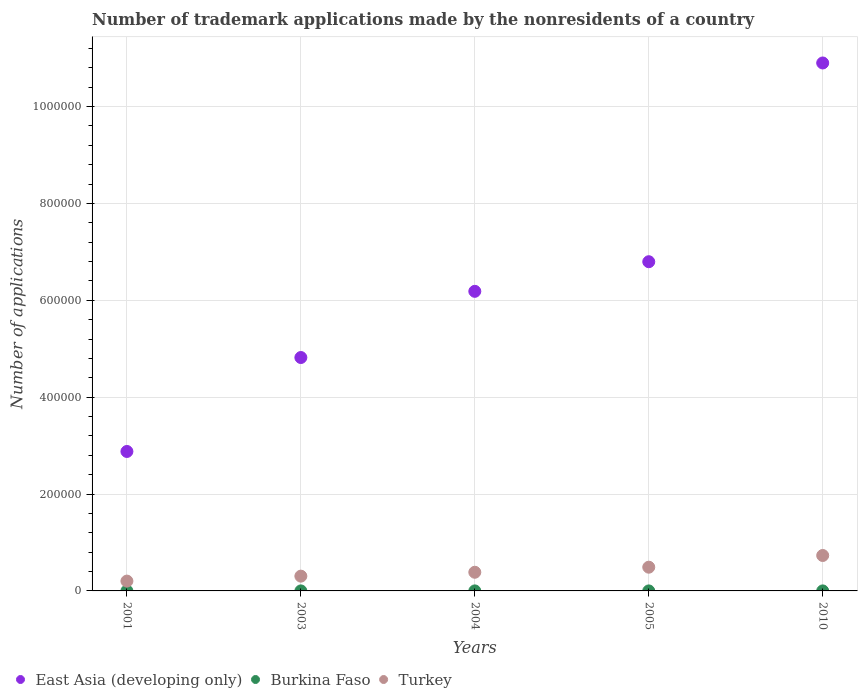Is the number of dotlines equal to the number of legend labels?
Keep it short and to the point. Yes. What is the number of trademark applications made by the nonresidents in East Asia (developing only) in 2010?
Provide a short and direct response. 1.09e+06. Across all years, what is the maximum number of trademark applications made by the nonresidents in East Asia (developing only)?
Give a very brief answer. 1.09e+06. Across all years, what is the minimum number of trademark applications made by the nonresidents in Turkey?
Offer a very short reply. 2.03e+04. In which year was the number of trademark applications made by the nonresidents in Burkina Faso minimum?
Offer a very short reply. 2001. What is the total number of trademark applications made by the nonresidents in Turkey in the graph?
Your answer should be compact. 2.11e+05. What is the difference between the number of trademark applications made by the nonresidents in East Asia (developing only) in 2001 and that in 2003?
Keep it short and to the point. -1.94e+05. What is the difference between the number of trademark applications made by the nonresidents in Turkey in 2004 and the number of trademark applications made by the nonresidents in Burkina Faso in 2001?
Give a very brief answer. 3.85e+04. What is the average number of trademark applications made by the nonresidents in Turkey per year?
Offer a terse response. 4.23e+04. In the year 2001, what is the difference between the number of trademark applications made by the nonresidents in Turkey and number of trademark applications made by the nonresidents in East Asia (developing only)?
Keep it short and to the point. -2.68e+05. In how many years, is the number of trademark applications made by the nonresidents in East Asia (developing only) greater than 560000?
Your response must be concise. 3. What is the ratio of the number of trademark applications made by the nonresidents in Burkina Faso in 2003 to that in 2010?
Provide a short and direct response. 1.03. Is the number of trademark applications made by the nonresidents in Burkina Faso in 2001 less than that in 2004?
Ensure brevity in your answer.  Yes. Is the difference between the number of trademark applications made by the nonresidents in Turkey in 2001 and 2005 greater than the difference between the number of trademark applications made by the nonresidents in East Asia (developing only) in 2001 and 2005?
Provide a succinct answer. Yes. What is the difference between the highest and the second highest number of trademark applications made by the nonresidents in Turkey?
Make the answer very short. 2.42e+04. Is the sum of the number of trademark applications made by the nonresidents in Turkey in 2003 and 2004 greater than the maximum number of trademark applications made by the nonresidents in Burkina Faso across all years?
Provide a short and direct response. Yes. Is it the case that in every year, the sum of the number of trademark applications made by the nonresidents in East Asia (developing only) and number of trademark applications made by the nonresidents in Burkina Faso  is greater than the number of trademark applications made by the nonresidents in Turkey?
Your answer should be very brief. Yes. How many dotlines are there?
Ensure brevity in your answer.  3. How many years are there in the graph?
Your response must be concise. 5. Are the values on the major ticks of Y-axis written in scientific E-notation?
Provide a short and direct response. No. How many legend labels are there?
Provide a short and direct response. 3. What is the title of the graph?
Your answer should be compact. Number of trademark applications made by the nonresidents of a country. What is the label or title of the Y-axis?
Ensure brevity in your answer.  Number of applications. What is the Number of applications in East Asia (developing only) in 2001?
Ensure brevity in your answer.  2.88e+05. What is the Number of applications of Burkina Faso in 2001?
Make the answer very short. 15. What is the Number of applications of Turkey in 2001?
Offer a very short reply. 2.03e+04. What is the Number of applications in East Asia (developing only) in 2003?
Ensure brevity in your answer.  4.82e+05. What is the Number of applications in Burkina Faso in 2003?
Ensure brevity in your answer.  35. What is the Number of applications of Turkey in 2003?
Provide a succinct answer. 3.05e+04. What is the Number of applications in East Asia (developing only) in 2004?
Offer a terse response. 6.18e+05. What is the Number of applications in Burkina Faso in 2004?
Your answer should be compact. 42. What is the Number of applications of Turkey in 2004?
Keep it short and to the point. 3.85e+04. What is the Number of applications of East Asia (developing only) in 2005?
Provide a short and direct response. 6.80e+05. What is the Number of applications of Turkey in 2005?
Your answer should be compact. 4.90e+04. What is the Number of applications of East Asia (developing only) in 2010?
Your answer should be very brief. 1.09e+06. What is the Number of applications in Burkina Faso in 2010?
Offer a terse response. 34. What is the Number of applications in Turkey in 2010?
Ensure brevity in your answer.  7.31e+04. Across all years, what is the maximum Number of applications in East Asia (developing only)?
Ensure brevity in your answer.  1.09e+06. Across all years, what is the maximum Number of applications of Burkina Faso?
Ensure brevity in your answer.  42. Across all years, what is the maximum Number of applications of Turkey?
Provide a succinct answer. 7.31e+04. Across all years, what is the minimum Number of applications of East Asia (developing only)?
Give a very brief answer. 2.88e+05. Across all years, what is the minimum Number of applications of Burkina Faso?
Provide a short and direct response. 15. Across all years, what is the minimum Number of applications of Turkey?
Offer a very short reply. 2.03e+04. What is the total Number of applications in East Asia (developing only) in the graph?
Offer a terse response. 3.16e+06. What is the total Number of applications in Burkina Faso in the graph?
Keep it short and to the point. 156. What is the total Number of applications in Turkey in the graph?
Your response must be concise. 2.11e+05. What is the difference between the Number of applications in East Asia (developing only) in 2001 and that in 2003?
Keep it short and to the point. -1.94e+05. What is the difference between the Number of applications in Burkina Faso in 2001 and that in 2003?
Give a very brief answer. -20. What is the difference between the Number of applications of Turkey in 2001 and that in 2003?
Offer a terse response. -1.02e+04. What is the difference between the Number of applications of East Asia (developing only) in 2001 and that in 2004?
Keep it short and to the point. -3.31e+05. What is the difference between the Number of applications in Burkina Faso in 2001 and that in 2004?
Your answer should be compact. -27. What is the difference between the Number of applications of Turkey in 2001 and that in 2004?
Your answer should be very brief. -1.82e+04. What is the difference between the Number of applications of East Asia (developing only) in 2001 and that in 2005?
Your response must be concise. -3.92e+05. What is the difference between the Number of applications in Turkey in 2001 and that in 2005?
Your response must be concise. -2.87e+04. What is the difference between the Number of applications of East Asia (developing only) in 2001 and that in 2010?
Your answer should be compact. -8.02e+05. What is the difference between the Number of applications in Burkina Faso in 2001 and that in 2010?
Make the answer very short. -19. What is the difference between the Number of applications in Turkey in 2001 and that in 2010?
Provide a short and direct response. -5.29e+04. What is the difference between the Number of applications in East Asia (developing only) in 2003 and that in 2004?
Your answer should be compact. -1.37e+05. What is the difference between the Number of applications of Turkey in 2003 and that in 2004?
Keep it short and to the point. -8017. What is the difference between the Number of applications of East Asia (developing only) in 2003 and that in 2005?
Keep it short and to the point. -1.98e+05. What is the difference between the Number of applications of Turkey in 2003 and that in 2005?
Your answer should be compact. -1.85e+04. What is the difference between the Number of applications in East Asia (developing only) in 2003 and that in 2010?
Offer a very short reply. -6.08e+05. What is the difference between the Number of applications of Turkey in 2003 and that in 2010?
Provide a short and direct response. -4.26e+04. What is the difference between the Number of applications in East Asia (developing only) in 2004 and that in 2005?
Provide a succinct answer. -6.11e+04. What is the difference between the Number of applications of Burkina Faso in 2004 and that in 2005?
Offer a very short reply. 12. What is the difference between the Number of applications of Turkey in 2004 and that in 2005?
Provide a succinct answer. -1.05e+04. What is the difference between the Number of applications of East Asia (developing only) in 2004 and that in 2010?
Ensure brevity in your answer.  -4.71e+05. What is the difference between the Number of applications of Burkina Faso in 2004 and that in 2010?
Provide a succinct answer. 8. What is the difference between the Number of applications of Turkey in 2004 and that in 2010?
Ensure brevity in your answer.  -3.46e+04. What is the difference between the Number of applications of East Asia (developing only) in 2005 and that in 2010?
Provide a succinct answer. -4.10e+05. What is the difference between the Number of applications of Turkey in 2005 and that in 2010?
Make the answer very short. -2.42e+04. What is the difference between the Number of applications in East Asia (developing only) in 2001 and the Number of applications in Burkina Faso in 2003?
Give a very brief answer. 2.88e+05. What is the difference between the Number of applications in East Asia (developing only) in 2001 and the Number of applications in Turkey in 2003?
Ensure brevity in your answer.  2.57e+05. What is the difference between the Number of applications in Burkina Faso in 2001 and the Number of applications in Turkey in 2003?
Provide a succinct answer. -3.05e+04. What is the difference between the Number of applications of East Asia (developing only) in 2001 and the Number of applications of Burkina Faso in 2004?
Give a very brief answer. 2.88e+05. What is the difference between the Number of applications in East Asia (developing only) in 2001 and the Number of applications in Turkey in 2004?
Keep it short and to the point. 2.49e+05. What is the difference between the Number of applications of Burkina Faso in 2001 and the Number of applications of Turkey in 2004?
Offer a terse response. -3.85e+04. What is the difference between the Number of applications of East Asia (developing only) in 2001 and the Number of applications of Burkina Faso in 2005?
Make the answer very short. 2.88e+05. What is the difference between the Number of applications in East Asia (developing only) in 2001 and the Number of applications in Turkey in 2005?
Ensure brevity in your answer.  2.39e+05. What is the difference between the Number of applications in Burkina Faso in 2001 and the Number of applications in Turkey in 2005?
Make the answer very short. -4.90e+04. What is the difference between the Number of applications in East Asia (developing only) in 2001 and the Number of applications in Burkina Faso in 2010?
Provide a short and direct response. 2.88e+05. What is the difference between the Number of applications in East Asia (developing only) in 2001 and the Number of applications in Turkey in 2010?
Your answer should be very brief. 2.15e+05. What is the difference between the Number of applications of Burkina Faso in 2001 and the Number of applications of Turkey in 2010?
Your answer should be very brief. -7.31e+04. What is the difference between the Number of applications of East Asia (developing only) in 2003 and the Number of applications of Burkina Faso in 2004?
Your answer should be compact. 4.82e+05. What is the difference between the Number of applications of East Asia (developing only) in 2003 and the Number of applications of Turkey in 2004?
Offer a terse response. 4.43e+05. What is the difference between the Number of applications of Burkina Faso in 2003 and the Number of applications of Turkey in 2004?
Provide a succinct answer. -3.85e+04. What is the difference between the Number of applications in East Asia (developing only) in 2003 and the Number of applications in Burkina Faso in 2005?
Provide a short and direct response. 4.82e+05. What is the difference between the Number of applications of East Asia (developing only) in 2003 and the Number of applications of Turkey in 2005?
Offer a very short reply. 4.33e+05. What is the difference between the Number of applications of Burkina Faso in 2003 and the Number of applications of Turkey in 2005?
Your answer should be very brief. -4.89e+04. What is the difference between the Number of applications in East Asia (developing only) in 2003 and the Number of applications in Burkina Faso in 2010?
Keep it short and to the point. 4.82e+05. What is the difference between the Number of applications in East Asia (developing only) in 2003 and the Number of applications in Turkey in 2010?
Ensure brevity in your answer.  4.09e+05. What is the difference between the Number of applications in Burkina Faso in 2003 and the Number of applications in Turkey in 2010?
Make the answer very short. -7.31e+04. What is the difference between the Number of applications in East Asia (developing only) in 2004 and the Number of applications in Burkina Faso in 2005?
Offer a very short reply. 6.18e+05. What is the difference between the Number of applications in East Asia (developing only) in 2004 and the Number of applications in Turkey in 2005?
Your answer should be very brief. 5.69e+05. What is the difference between the Number of applications of Burkina Faso in 2004 and the Number of applications of Turkey in 2005?
Your answer should be compact. -4.89e+04. What is the difference between the Number of applications of East Asia (developing only) in 2004 and the Number of applications of Burkina Faso in 2010?
Provide a succinct answer. 6.18e+05. What is the difference between the Number of applications in East Asia (developing only) in 2004 and the Number of applications in Turkey in 2010?
Give a very brief answer. 5.45e+05. What is the difference between the Number of applications of Burkina Faso in 2004 and the Number of applications of Turkey in 2010?
Provide a short and direct response. -7.31e+04. What is the difference between the Number of applications in East Asia (developing only) in 2005 and the Number of applications in Burkina Faso in 2010?
Offer a terse response. 6.80e+05. What is the difference between the Number of applications in East Asia (developing only) in 2005 and the Number of applications in Turkey in 2010?
Offer a terse response. 6.06e+05. What is the difference between the Number of applications of Burkina Faso in 2005 and the Number of applications of Turkey in 2010?
Make the answer very short. -7.31e+04. What is the average Number of applications in East Asia (developing only) per year?
Your answer should be compact. 6.32e+05. What is the average Number of applications of Burkina Faso per year?
Ensure brevity in your answer.  31.2. What is the average Number of applications of Turkey per year?
Give a very brief answer. 4.23e+04. In the year 2001, what is the difference between the Number of applications in East Asia (developing only) and Number of applications in Burkina Faso?
Keep it short and to the point. 2.88e+05. In the year 2001, what is the difference between the Number of applications in East Asia (developing only) and Number of applications in Turkey?
Offer a terse response. 2.68e+05. In the year 2001, what is the difference between the Number of applications in Burkina Faso and Number of applications in Turkey?
Your answer should be compact. -2.03e+04. In the year 2003, what is the difference between the Number of applications in East Asia (developing only) and Number of applications in Burkina Faso?
Make the answer very short. 4.82e+05. In the year 2003, what is the difference between the Number of applications of East Asia (developing only) and Number of applications of Turkey?
Your response must be concise. 4.51e+05. In the year 2003, what is the difference between the Number of applications of Burkina Faso and Number of applications of Turkey?
Keep it short and to the point. -3.05e+04. In the year 2004, what is the difference between the Number of applications in East Asia (developing only) and Number of applications in Burkina Faso?
Make the answer very short. 6.18e+05. In the year 2004, what is the difference between the Number of applications of East Asia (developing only) and Number of applications of Turkey?
Offer a terse response. 5.80e+05. In the year 2004, what is the difference between the Number of applications of Burkina Faso and Number of applications of Turkey?
Ensure brevity in your answer.  -3.85e+04. In the year 2005, what is the difference between the Number of applications of East Asia (developing only) and Number of applications of Burkina Faso?
Give a very brief answer. 6.80e+05. In the year 2005, what is the difference between the Number of applications of East Asia (developing only) and Number of applications of Turkey?
Keep it short and to the point. 6.31e+05. In the year 2005, what is the difference between the Number of applications in Burkina Faso and Number of applications in Turkey?
Ensure brevity in your answer.  -4.90e+04. In the year 2010, what is the difference between the Number of applications of East Asia (developing only) and Number of applications of Burkina Faso?
Offer a very short reply. 1.09e+06. In the year 2010, what is the difference between the Number of applications in East Asia (developing only) and Number of applications in Turkey?
Provide a succinct answer. 1.02e+06. In the year 2010, what is the difference between the Number of applications in Burkina Faso and Number of applications in Turkey?
Ensure brevity in your answer.  -7.31e+04. What is the ratio of the Number of applications in East Asia (developing only) in 2001 to that in 2003?
Provide a succinct answer. 0.6. What is the ratio of the Number of applications of Burkina Faso in 2001 to that in 2003?
Ensure brevity in your answer.  0.43. What is the ratio of the Number of applications of Turkey in 2001 to that in 2003?
Provide a short and direct response. 0.67. What is the ratio of the Number of applications of East Asia (developing only) in 2001 to that in 2004?
Provide a short and direct response. 0.47. What is the ratio of the Number of applications in Burkina Faso in 2001 to that in 2004?
Give a very brief answer. 0.36. What is the ratio of the Number of applications of Turkey in 2001 to that in 2004?
Provide a short and direct response. 0.53. What is the ratio of the Number of applications in East Asia (developing only) in 2001 to that in 2005?
Give a very brief answer. 0.42. What is the ratio of the Number of applications of Burkina Faso in 2001 to that in 2005?
Your answer should be very brief. 0.5. What is the ratio of the Number of applications in Turkey in 2001 to that in 2005?
Provide a succinct answer. 0.41. What is the ratio of the Number of applications of East Asia (developing only) in 2001 to that in 2010?
Offer a very short reply. 0.26. What is the ratio of the Number of applications of Burkina Faso in 2001 to that in 2010?
Your answer should be very brief. 0.44. What is the ratio of the Number of applications of Turkey in 2001 to that in 2010?
Make the answer very short. 0.28. What is the ratio of the Number of applications of East Asia (developing only) in 2003 to that in 2004?
Your response must be concise. 0.78. What is the ratio of the Number of applications of Turkey in 2003 to that in 2004?
Make the answer very short. 0.79. What is the ratio of the Number of applications of East Asia (developing only) in 2003 to that in 2005?
Provide a succinct answer. 0.71. What is the ratio of the Number of applications in Turkey in 2003 to that in 2005?
Give a very brief answer. 0.62. What is the ratio of the Number of applications of East Asia (developing only) in 2003 to that in 2010?
Offer a terse response. 0.44. What is the ratio of the Number of applications in Burkina Faso in 2003 to that in 2010?
Provide a short and direct response. 1.03. What is the ratio of the Number of applications of Turkey in 2003 to that in 2010?
Provide a succinct answer. 0.42. What is the ratio of the Number of applications in East Asia (developing only) in 2004 to that in 2005?
Make the answer very short. 0.91. What is the ratio of the Number of applications in Burkina Faso in 2004 to that in 2005?
Offer a terse response. 1.4. What is the ratio of the Number of applications in Turkey in 2004 to that in 2005?
Your response must be concise. 0.79. What is the ratio of the Number of applications in East Asia (developing only) in 2004 to that in 2010?
Give a very brief answer. 0.57. What is the ratio of the Number of applications of Burkina Faso in 2004 to that in 2010?
Provide a succinct answer. 1.24. What is the ratio of the Number of applications of Turkey in 2004 to that in 2010?
Offer a terse response. 0.53. What is the ratio of the Number of applications in East Asia (developing only) in 2005 to that in 2010?
Ensure brevity in your answer.  0.62. What is the ratio of the Number of applications of Burkina Faso in 2005 to that in 2010?
Your answer should be very brief. 0.88. What is the ratio of the Number of applications of Turkey in 2005 to that in 2010?
Offer a very short reply. 0.67. What is the difference between the highest and the second highest Number of applications in East Asia (developing only)?
Provide a succinct answer. 4.10e+05. What is the difference between the highest and the second highest Number of applications of Burkina Faso?
Keep it short and to the point. 7. What is the difference between the highest and the second highest Number of applications in Turkey?
Your answer should be very brief. 2.42e+04. What is the difference between the highest and the lowest Number of applications of East Asia (developing only)?
Give a very brief answer. 8.02e+05. What is the difference between the highest and the lowest Number of applications in Turkey?
Give a very brief answer. 5.29e+04. 